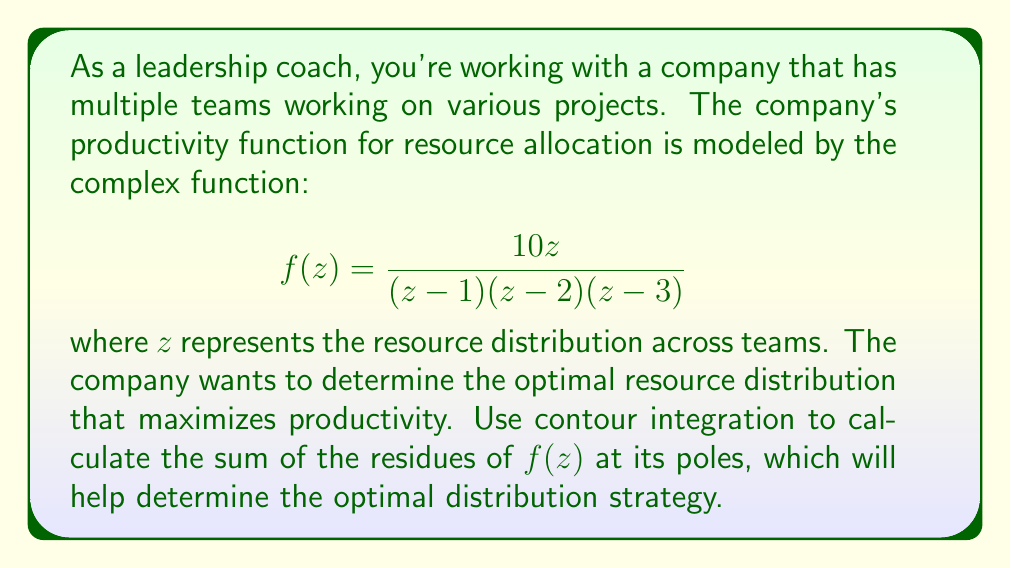Solve this math problem. To solve this problem using contour integration, we'll follow these steps:

1) First, identify the poles of the function. The poles are at $z = 1$, $z = 2$, and $z = 3$.

2) The sum of the residues at these poles will be equal to the contour integral of $f(z)$ around a large circle that encloses all the poles, divided by $2\pi i$.

3) To find the residues, we'll use the formula for simple poles:
   $$\text{Res}(f, a) = \lim_{z \to a} (z-a)f(z)$$

4) For $z = 1$:
   $$\text{Res}(f, 1) = \lim_{z \to 1} (z-1)\frac{10z}{(z-1)(z-2)(z-3)} = \frac{10}{(1-2)(1-3)} = 5$$

5) For $z = 2$:
   $$\text{Res}(f, 2) = \lim_{z \to 2} (z-2)\frac{10z}{(z-1)(z-2)(z-3)} = \frac{20}{(2-1)(2-3)} = -20$$

6) For $z = 3$:
   $$\text{Res}(f, 3) = \lim_{z \to 3} (z-3)\frac{10z}{(z-1)(z-2)(z-3)} = \frac{30}{(3-1)(3-2)} = 15$$

7) The sum of the residues is:
   $$5 + (-20) + 15 = 0$$

8) This means that the contour integral of $f(z)$ around a large circle is zero, implying that the function $f(z)$ approaches zero as $|z|$ approaches infinity.

9) In the context of resource distribution, this result suggests that extreme allocations (very large $|z|$) are not optimal. The optimal strategy likely involves a balanced distribution among the three key points (1, 2, and 3).

10) The negative residue at $z = 2$ indicates that allocating all resources to this point would be the least productive strategy.

11) The largest positive residue is at $z = 3$, suggesting that this point should receive the most resources, followed by $z = 1$.
Answer: The sum of the residues is 0. This indicates that the optimal resource distribution strategy should balance resources among the three key points (1, 2, and 3), with a preference for allocating more resources to point 3, followed by point 1, and the least to point 2. 